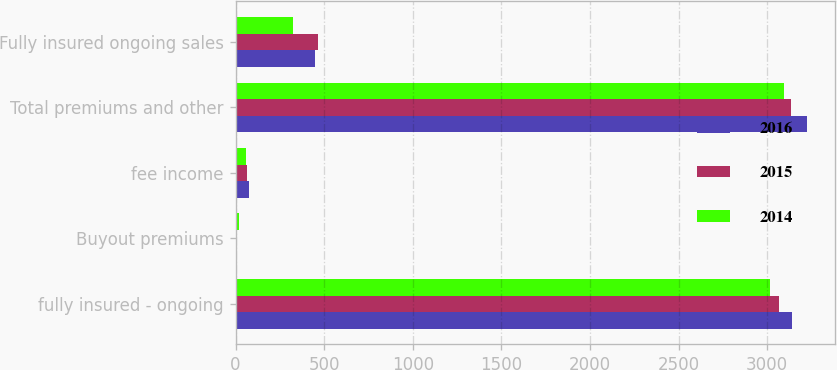Convert chart. <chart><loc_0><loc_0><loc_500><loc_500><stacked_bar_chart><ecel><fcel>fully insured - ongoing<fcel>Buyout premiums<fcel>fee income<fcel>Total premiums and other<fcel>Fully insured ongoing sales<nl><fcel>2016<fcel>3142<fcel>6<fcel>75<fcel>3223<fcel>450<nl><fcel>2015<fcel>3068<fcel>1<fcel>67<fcel>3136<fcel>467<nl><fcel>2014<fcel>3014<fcel>20<fcel>61<fcel>3095<fcel>326<nl></chart> 